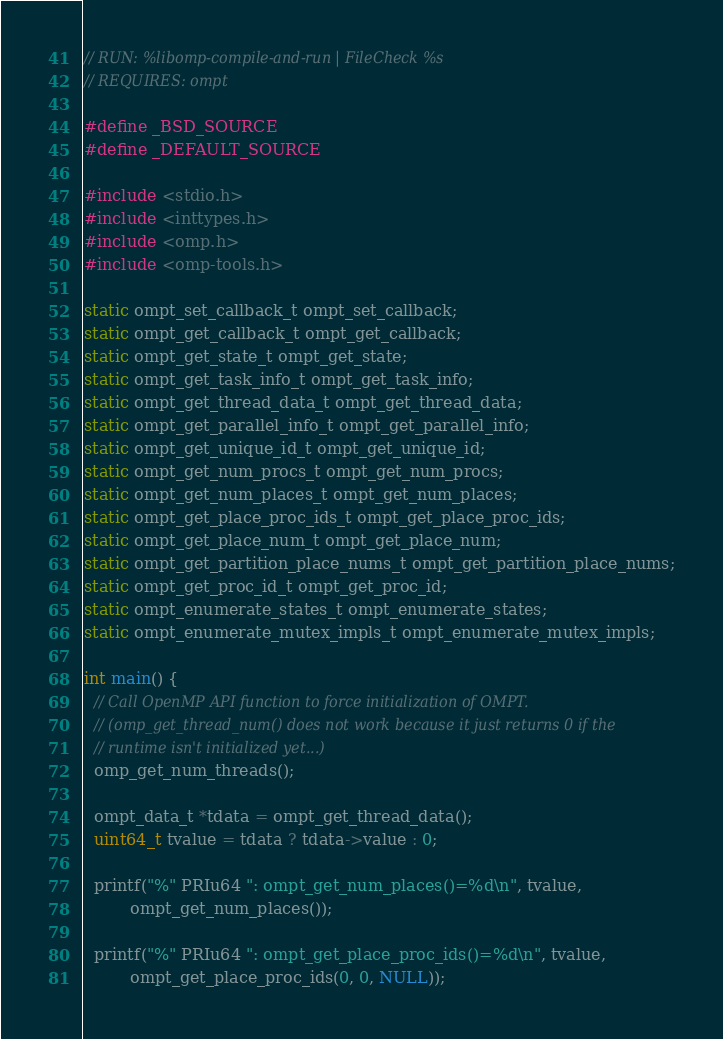<code> <loc_0><loc_0><loc_500><loc_500><_C_>// RUN: %libomp-compile-and-run | FileCheck %s
// REQUIRES: ompt

#define _BSD_SOURCE
#define _DEFAULT_SOURCE

#include <stdio.h>
#include <inttypes.h>
#include <omp.h>
#include <omp-tools.h>

static ompt_set_callback_t ompt_set_callback;
static ompt_get_callback_t ompt_get_callback;
static ompt_get_state_t ompt_get_state;
static ompt_get_task_info_t ompt_get_task_info;
static ompt_get_thread_data_t ompt_get_thread_data;
static ompt_get_parallel_info_t ompt_get_parallel_info;
static ompt_get_unique_id_t ompt_get_unique_id;
static ompt_get_num_procs_t ompt_get_num_procs;
static ompt_get_num_places_t ompt_get_num_places;
static ompt_get_place_proc_ids_t ompt_get_place_proc_ids;
static ompt_get_place_num_t ompt_get_place_num;
static ompt_get_partition_place_nums_t ompt_get_partition_place_nums;
static ompt_get_proc_id_t ompt_get_proc_id;
static ompt_enumerate_states_t ompt_enumerate_states;
static ompt_enumerate_mutex_impls_t ompt_enumerate_mutex_impls;

int main() {
  // Call OpenMP API function to force initialization of OMPT.
  // (omp_get_thread_num() does not work because it just returns 0 if the
  // runtime isn't initialized yet...)
  omp_get_num_threads();

  ompt_data_t *tdata = ompt_get_thread_data();
  uint64_t tvalue = tdata ? tdata->value : 0;

  printf("%" PRIu64 ": ompt_get_num_places()=%d\n", tvalue,
         ompt_get_num_places());

  printf("%" PRIu64 ": ompt_get_place_proc_ids()=%d\n", tvalue,
         ompt_get_place_proc_ids(0, 0, NULL));
</code> 